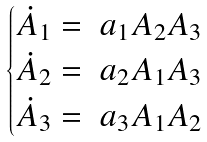Convert formula to latex. <formula><loc_0><loc_0><loc_500><loc_500>\begin{cases} \dot { A } _ { 1 } = \ a _ { 1 } A _ { 2 } A _ { 3 } \\ \dot { A } _ { 2 } = \ a _ { 2 } A _ { 1 } A _ { 3 } \\ \dot { A } _ { 3 } = \ a _ { 3 } A _ { 1 } A _ { 2 } \end{cases}</formula> 